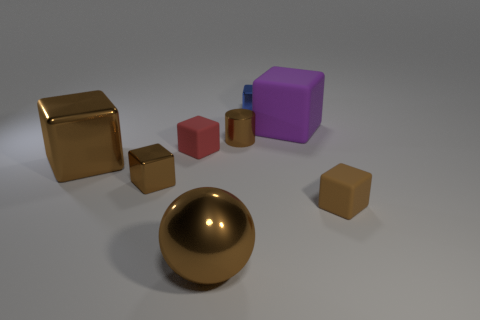There is a brown thing that is the same material as the purple object; what is its shape?
Your response must be concise. Cube. There is a big brown thing behind the small brown rubber object; does it have the same shape as the brown thing right of the blue cube?
Provide a short and direct response. Yes. Are there fewer brown shiny spheres that are to the right of the big purple thing than red matte objects on the left side of the red matte thing?
Your response must be concise. No. What shape is the large metallic object that is the same color as the metal sphere?
Your answer should be very brief. Cube. What number of green rubber blocks have the same size as the blue cube?
Your answer should be very brief. 0. Are the brown object that is on the right side of the tiny blue metallic cube and the sphere made of the same material?
Keep it short and to the point. No. Are any tiny red metal things visible?
Your response must be concise. No. What size is the red cube that is the same material as the purple block?
Give a very brief answer. Small. Are there any rubber cubes of the same color as the cylinder?
Provide a succinct answer. Yes. There is a small matte cube to the left of the purple thing; is it the same color as the tiny cube behind the brown metal cylinder?
Give a very brief answer. No. 